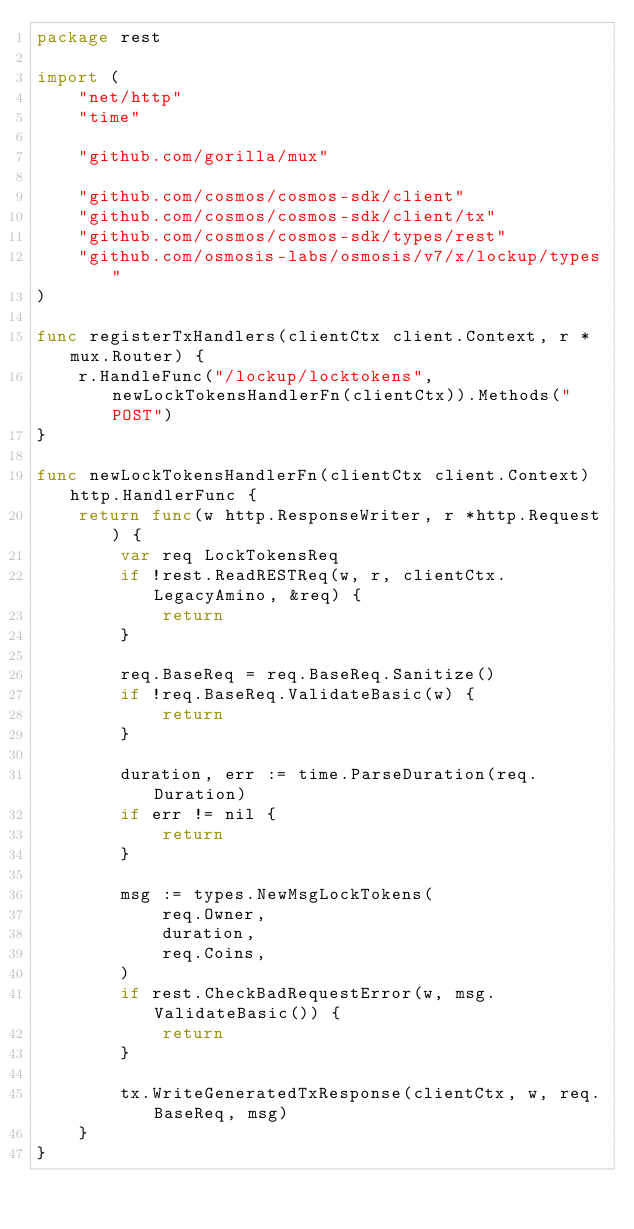<code> <loc_0><loc_0><loc_500><loc_500><_Go_>package rest

import (
	"net/http"
	"time"

	"github.com/gorilla/mux"

	"github.com/cosmos/cosmos-sdk/client"
	"github.com/cosmos/cosmos-sdk/client/tx"
	"github.com/cosmos/cosmos-sdk/types/rest"
	"github.com/osmosis-labs/osmosis/v7/x/lockup/types"
)

func registerTxHandlers(clientCtx client.Context, r *mux.Router) {
	r.HandleFunc("/lockup/locktokens", newLockTokensHandlerFn(clientCtx)).Methods("POST")
}

func newLockTokensHandlerFn(clientCtx client.Context) http.HandlerFunc {
	return func(w http.ResponseWriter, r *http.Request) {
		var req LockTokensReq
		if !rest.ReadRESTReq(w, r, clientCtx.LegacyAmino, &req) {
			return
		}

		req.BaseReq = req.BaseReq.Sanitize()
		if !req.BaseReq.ValidateBasic(w) {
			return
		}

		duration, err := time.ParseDuration(req.Duration)
		if err != nil {
			return
		}

		msg := types.NewMsgLockTokens(
			req.Owner,
			duration,
			req.Coins,
		)
		if rest.CheckBadRequestError(w, msg.ValidateBasic()) {
			return
		}

		tx.WriteGeneratedTxResponse(clientCtx, w, req.BaseReq, msg)
	}
}
</code> 